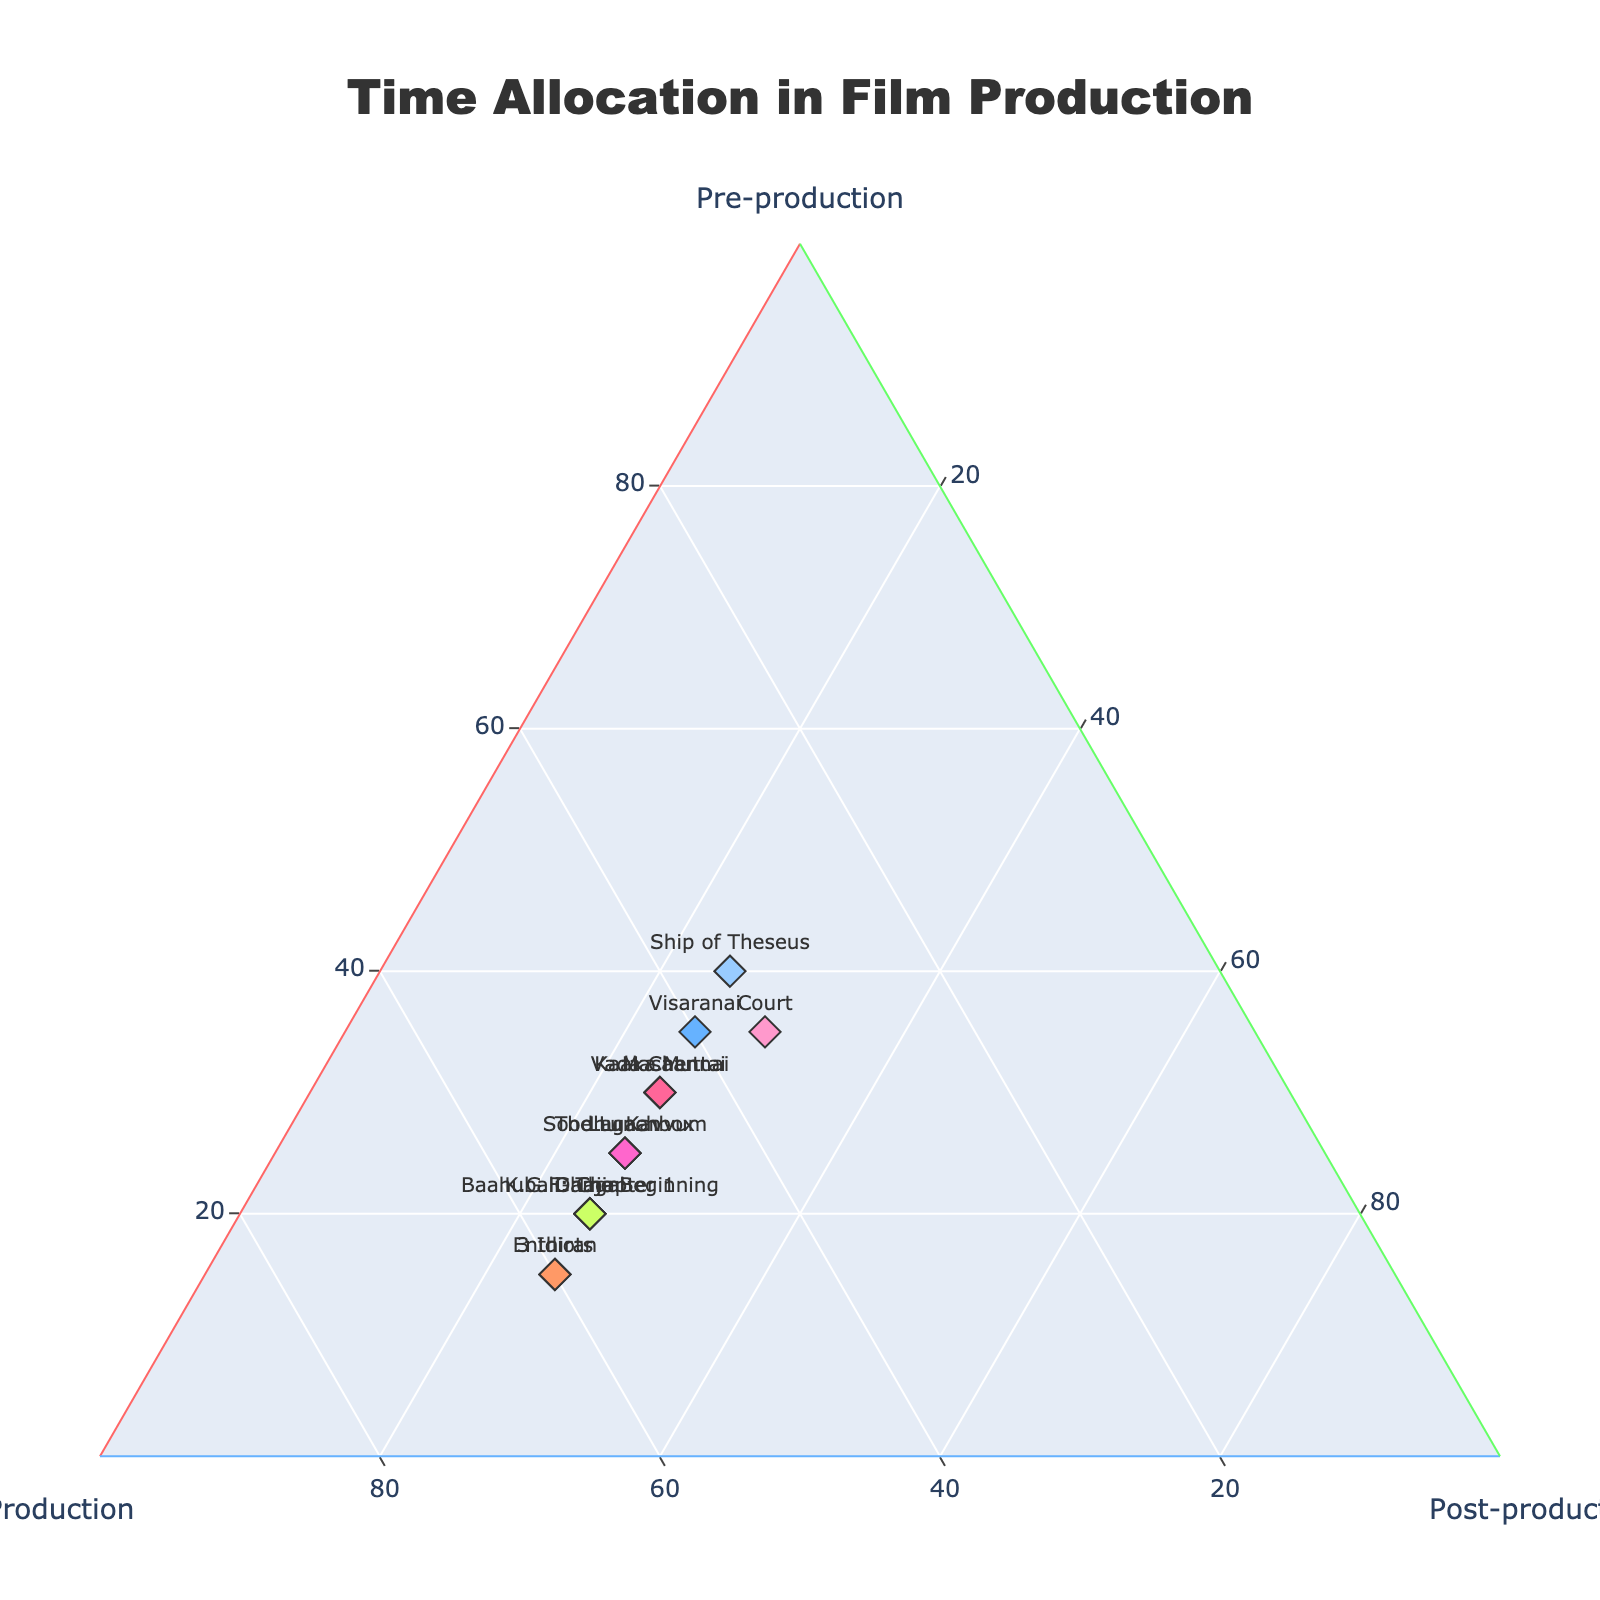what is the title of this plot? The title is located at the top center of the figure. It is a direct reference to the overall subject of the plot.
Answer: Time Allocation in Film Production What are the axes titles of the ternary plot? The axis titles are located at the corners of the ternary plot, each representing a different phase of film production.
Answer: Pre-production, Production, Post-production How many data points are there in the figure? Each data point represents one film, and each is labeled and marked distinctly.
Answer: 15 Which two films have the same time allocation for all phases of production? By closely observing the time allocation values for each film, two films with identical values can be identified.
Answer: Kaaka Muttai and Masaan Is there a film that spends equal time on pre-production and post-production? Look for the data point where the values of pre-production and post-production match.
Answer: Court Which film allocates the most time to pre-production? The film closest to the 'Pre-production' axis vertex will have the highest allocation in this category.
Answer: Ship of Theseus How does the time allocation for Vada Chennai compare to Kaaka Muttai in terms of production phase? Check the production values for both films and compare them.
Answer: Both have 45% of their time allocated to production What is the average percentage of time allocated to production for studio productions (assume Baahubali, Enthiran, and Dangal are studio productions)? Sum the production time for the three films and divide by the number of films.
Answer: (55 + 60 + 55) / 3 = 56.67% Is there any data point located exactly at the center of the ternary plot? The center of the ternary plot would correspond to a value where all phases are equal (33.3%). Analyze if any film falls there.
Answer: No Which color is used for the film "Lagaan" on the plot? Each film is colored distinctly. Find the marker that represents "Lagaan" and identify its color.
Answer: A light green shade 